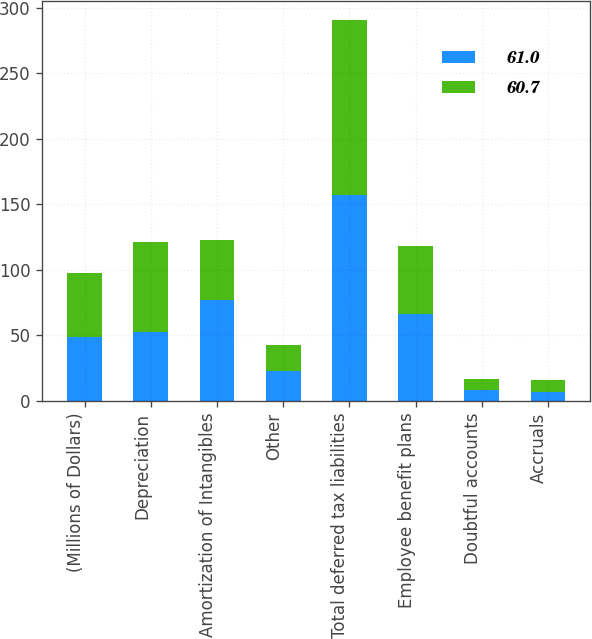<chart> <loc_0><loc_0><loc_500><loc_500><stacked_bar_chart><ecel><fcel>(Millions of Dollars)<fcel>Depreciation<fcel>Amortization of Intangibles<fcel>Other<fcel>Total deferred tax liabilities<fcel>Employee benefit plans<fcel>Doubtful accounts<fcel>Accruals<nl><fcel>61<fcel>48.8<fcel>52.8<fcel>76.9<fcel>22.9<fcel>157.2<fcel>66.2<fcel>8.6<fcel>6.6<nl><fcel>60.7<fcel>48.8<fcel>68.1<fcel>45.9<fcel>19.5<fcel>133.5<fcel>51.7<fcel>8.5<fcel>9.8<nl></chart> 